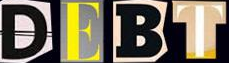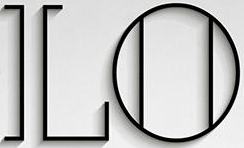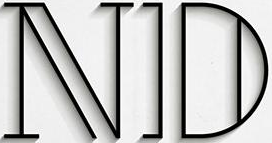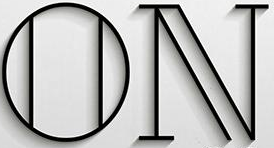Transcribe the words shown in these images in order, separated by a semicolon. DEBT; LO; ND; ON 